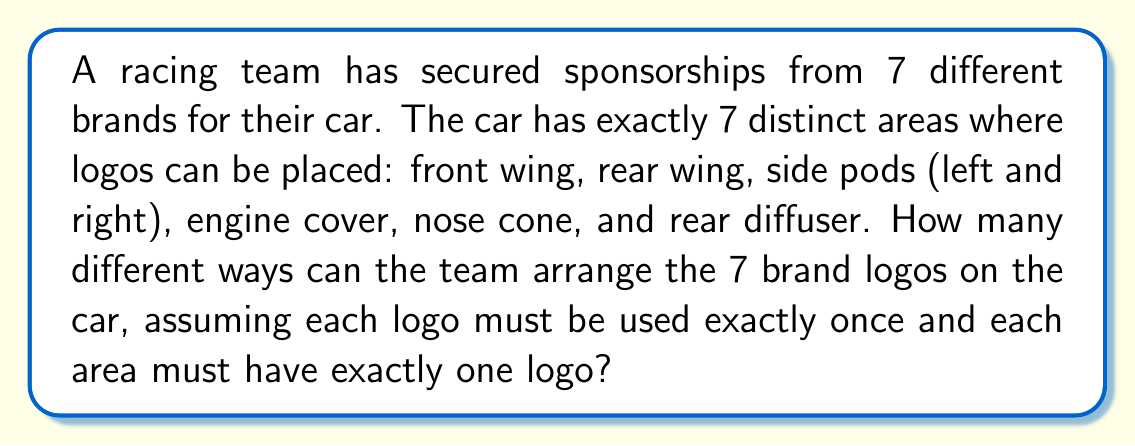Show me your answer to this math problem. To solve this problem, we need to recognize that this is a permutation question. We are arranging 7 distinct logos in 7 distinct positions, where each logo is used once and each position is filled.

1) This scenario is a perfect example of a permutation of 7 objects.

2) The formula for permutations of n distinct objects is:

   $$P(n) = n!$$

3) In this case, n = 7 (7 logos to arrange in 7 positions)

4) Therefore, the number of ways to arrange the logos is:

   $$P(7) = 7!$$

5) Let's calculate 7!:
   
   $$7! = 7 \times 6 \times 5 \times 4 \times 3 \times 2 \times 1 = 5040$$

Thus, there are 5040 different ways to arrange the 7 brand logos on the racing car.
Answer: 5040 